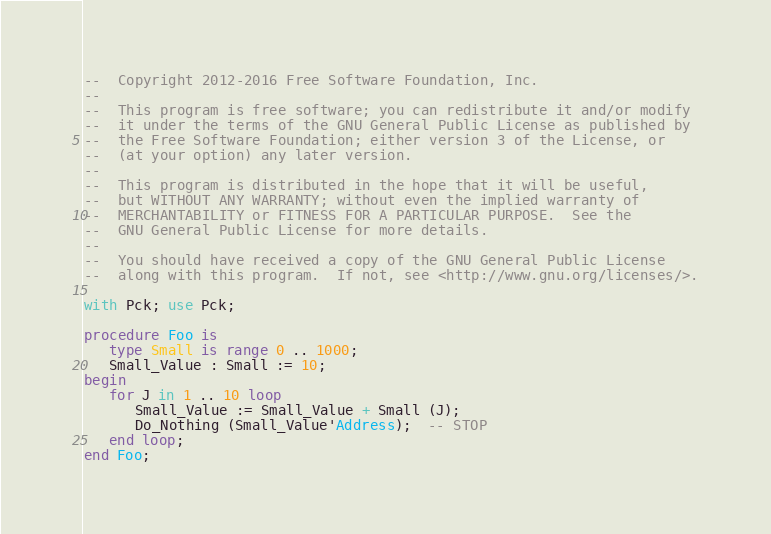Convert code to text. <code><loc_0><loc_0><loc_500><loc_500><_Ada_>--  Copyright 2012-2016 Free Software Foundation, Inc.
--
--  This program is free software; you can redistribute it and/or modify
--  it under the terms of the GNU General Public License as published by
--  the Free Software Foundation; either version 3 of the License, or
--  (at your option) any later version.
--
--  This program is distributed in the hope that it will be useful,
--  but WITHOUT ANY WARRANTY; without even the implied warranty of
--  MERCHANTABILITY or FITNESS FOR A PARTICULAR PURPOSE.  See the
--  GNU General Public License for more details.
--
--  You should have received a copy of the GNU General Public License
--  along with this program.  If not, see <http://www.gnu.org/licenses/>.

with Pck; use Pck;

procedure Foo is
   type Small is range 0 .. 1000;
   Small_Value : Small := 10;
begin
   for J in 1 .. 10 loop
      Small_Value := Small_Value + Small (J);
      Do_Nothing (Small_Value'Address);  -- STOP
   end loop;
end Foo;
</code> 